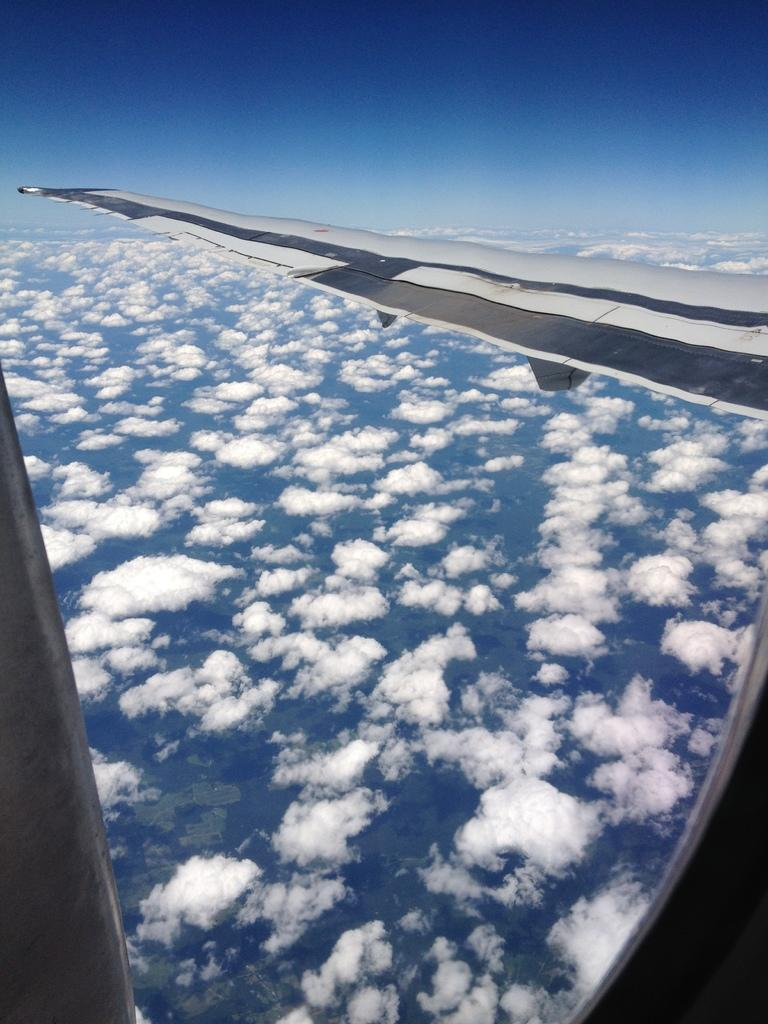What is the main subject of the picture? The main subject of the picture is an airplane wing. What can be seen in the background of the picture? The sky is visible in the background of the picture. What is the condition of the sky in the picture? Clouds are present in the sky. What type of silver vase can be seen on the curve of the airplane wing in the image? There is no vase, silver or otherwise, present on the airplane wing in the image. 